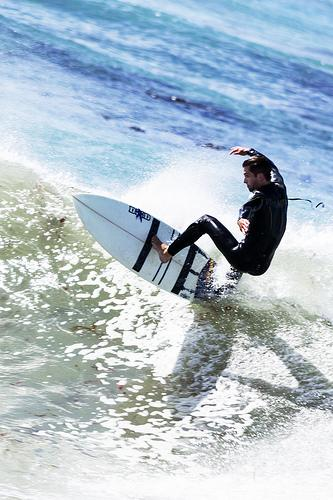Write a short sentence focusing on the man's appearance while surfing. The man in a black wetsuit is surfing with his right arm in the air and his foot exposed, revealing athletic prowess. Describe the water in the image. The water encompasses a mixture of dark blue, turquoise, and blue-white ocean waves with white foam and visible shadows. In one sentence, mention the main subject and the board they're using. A surfer wearing a wetsuit is skillfully riding a white surfboard with a black stripe. Summarize the image using present continuous tense. A man is skillfully surfing ocean waves on a black and white surfboard, wearing a black wetsuit and balancing with his arms outstretched. Briefly describe the image using only nouns and adjectives. Bearded man, black wetsuit, white surfboard, black stripe, blue ocean, white waves, surfing, balance, shadows. Compose a simple sentence describing the central focus of the image. A young surfer in a black wetsuit is riding a wave on a white surfboard. List the primary elements and colors you see in the image. Man in black wetsuit, white surfboard with black stripe, blue and white ocean waves, water spray, and shadows. In one sentence, explain what makes the man's outfit noteworthy in the image. The man stands out wearing a long-sleeved black wetsuit with no shoes while surfing. Mention the key components of the image in a brief sentence. A bearded man wearing a wetsuit is surfing on a white and black surfboard amidst blue and white waves. Express the primary action occurring in the image in one sentence. A surfer with an outstretched arm is navigating a wave on his black and white surfboard. 